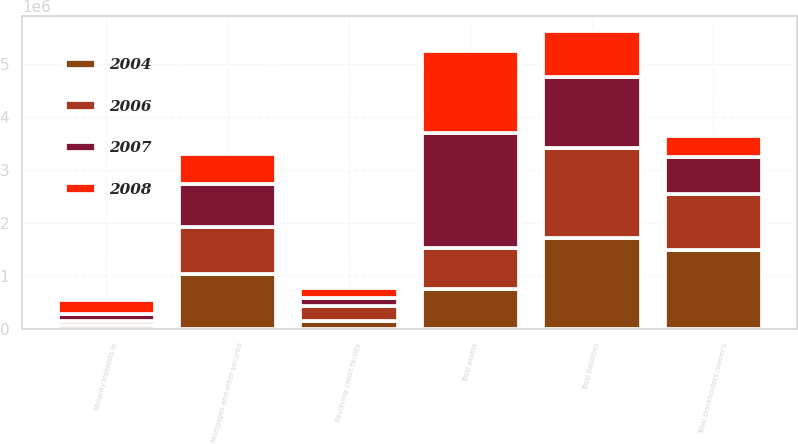<chart> <loc_0><loc_0><loc_500><loc_500><stacked_bar_chart><ecel><fcel>Total assets<fcel>Revolving credit facility<fcel>Mortgages and other secured<fcel>Total liabilities<fcel>Minority interests in<fcel>Total stockholders'/owner's<nl><fcel>2004<fcel>757229<fcel>138579<fcel>1.02659e+06<fcel>1.71657e+06<fcel>65916<fcel>1.49283e+06<nl><fcel>2006<fcel>757229<fcel>299731<fcel>895507<fcel>1.68764e+06<fcel>72983<fcel>1.04392e+06<nl><fcel>2007<fcel>2.18622e+06<fcel>145452<fcel>804686<fcel>1.33803e+06<fcel>138416<fcel>709772<nl><fcel>2008<fcel>1.52917e+06<fcel>181000<fcel>568067<fcel>880228<fcel>262239<fcel>386497<nl></chart> 